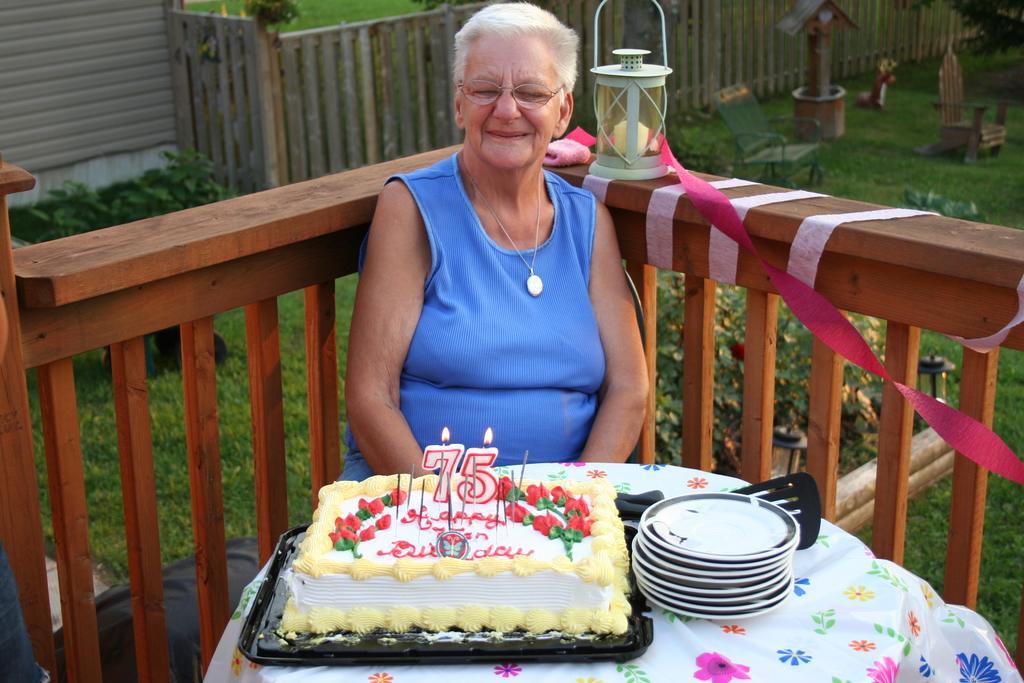Describe this image in one or two sentences. In this picture there is a old woman sitting in the chair in front of a table on which a cake and a plates were placed. Behind her there is a railing on which lamp is placed. In the background there is a garden in which some plants and a wall can be seen. 